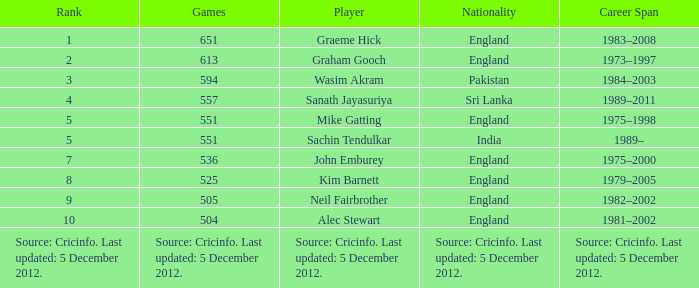What is Wasim Akram's rank? 3.0. 